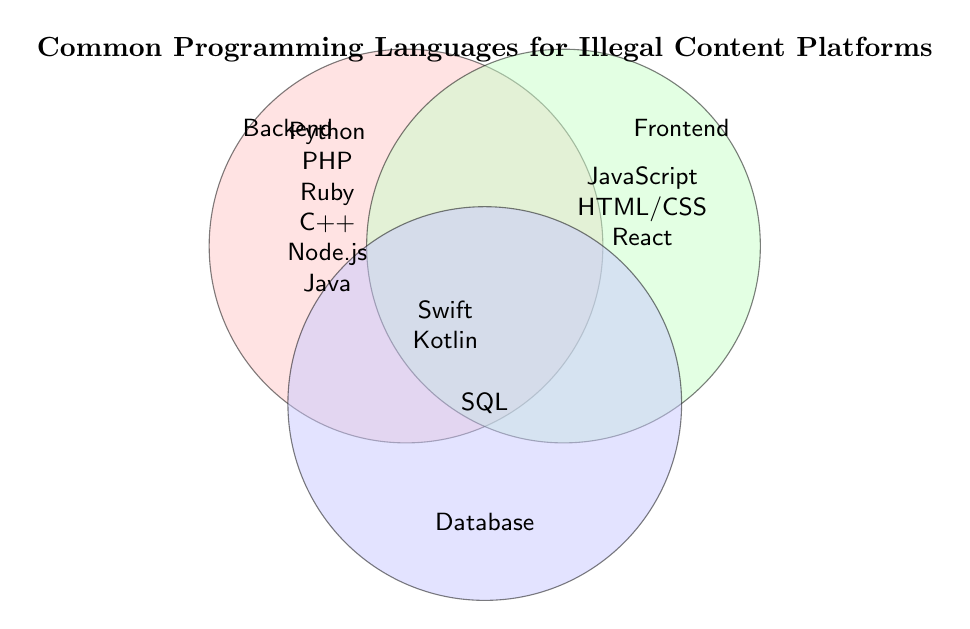Which programming languages are used for backend development? The figure shows that the backend development circle includes languages like Python, PHP, Ruby, C++, Node.js, and Java.
Answer: Python, PHP, Ruby, C++, Node.js, Java Which programming languages are used for frontend development? The figure shows that the frontend development circle includes JavaScript, HTML/CSS, and React.
Answer: JavaScript, HTML/CSS, React Which programming language is used for databases? The figure shows that the Database section includes SQL.
Answer: SQL Which languages are listed in both the backend and frontend circles? No languages are listed in the intersection of the backend and frontend circles indicating there are no common languages between these two sections.
Answer: None What languages are used for mobile development (iOS and Android)? The figure shows a shared space for mobile development languages, which includes Swift for iOS and Kotlin for Android.
Answer: Swift, Kotlin How does the number of backend languages compare to frontend languages? Count the languages listed for backend (6) and those for frontend (3), then compare the numbers. Backend has more languages.
Answer: Backend has more languages Is Node.js a backend or frontend language? According to the figure, Node.js is within the backend development circle.
Answer: Backend Which types of development use the least number of languages? Compare the number of languages listed in each section: Backend (6), Frontend (3), and Database (1). Database uses the least number of languages.
Answer: Database What is the visual title of the Venn diagram? The title is placed at the top of the figure and it states "Common Programming Languages for Illegal Content Platforms."
Answer: Common Programming Languages for Illegal Content Platforms Are PHP and Ruby categorized under the same type of development? Both PHP and Ruby are listed inside the backend development circle.
Answer: Yes 